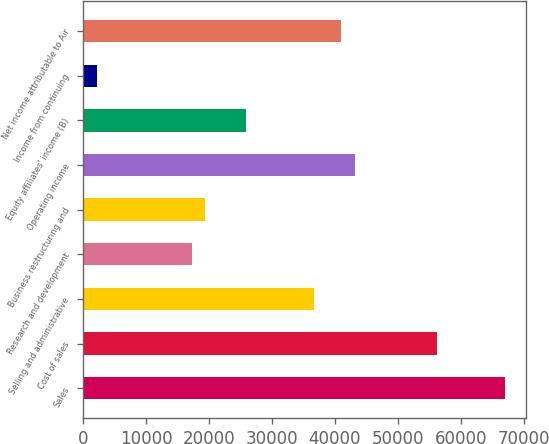Convert chart to OTSL. <chart><loc_0><loc_0><loc_500><loc_500><bar_chart><fcel>Sales<fcel>Cost of sales<fcel>Selling and administrative<fcel>Research and development<fcel>Business restructuring and<fcel>Operating income<fcel>Equity affiliates' income (B)<fcel>Income from continuing<fcel>Net income attributable to Air<nl><fcel>66954.1<fcel>56155.5<fcel>36718<fcel>17280.5<fcel>19440.2<fcel>43197.2<fcel>25919.4<fcel>2162.49<fcel>41037.4<nl></chart> 